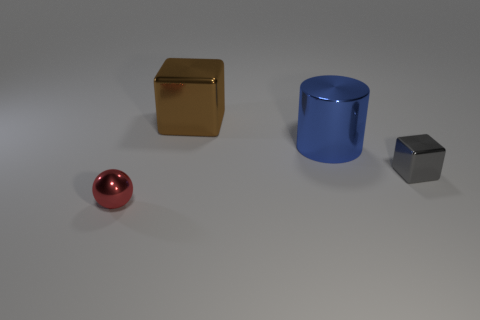Add 2 tiny gray objects. How many objects exist? 6 Subtract all balls. How many objects are left? 3 Subtract all big blue objects. Subtract all tiny things. How many objects are left? 1 Add 3 large blue things. How many large blue things are left? 4 Add 1 cylinders. How many cylinders exist? 2 Subtract 0 brown cylinders. How many objects are left? 4 